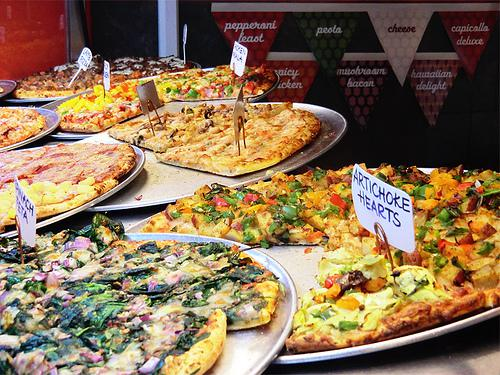Question: what part of the artichoke is on the pizza?
Choices:
A. The choke.
B. The inner bracts.
C. Hearts.
D. The outer bracts.
Answer with the letter. Answer: C Question: what does the white flag in the background say?
Choices:
A. Cheese.
B. Chinese.
C. Cheesy.
D. Cheeks.
Answer with the letter. Answer: A Question: what cheese is on the spinach pizza on the bottom?
Choices:
A. Feta.
B. Mozzarella.
C. Parmesan.
D. Gouda.
Answer with the letter. Answer: A Question: what food is in the picture?
Choices:
A. Pizza.
B. Pancakes.
C. Tortillas.
D. Naan bread.
Answer with the letter. Answer: A Question: what shape are the flags on the banner in the back?
Choices:
A. Triangles.
B. Circles.
C. Parallelograms.
D. Squares.
Answer with the letter. Answer: A 